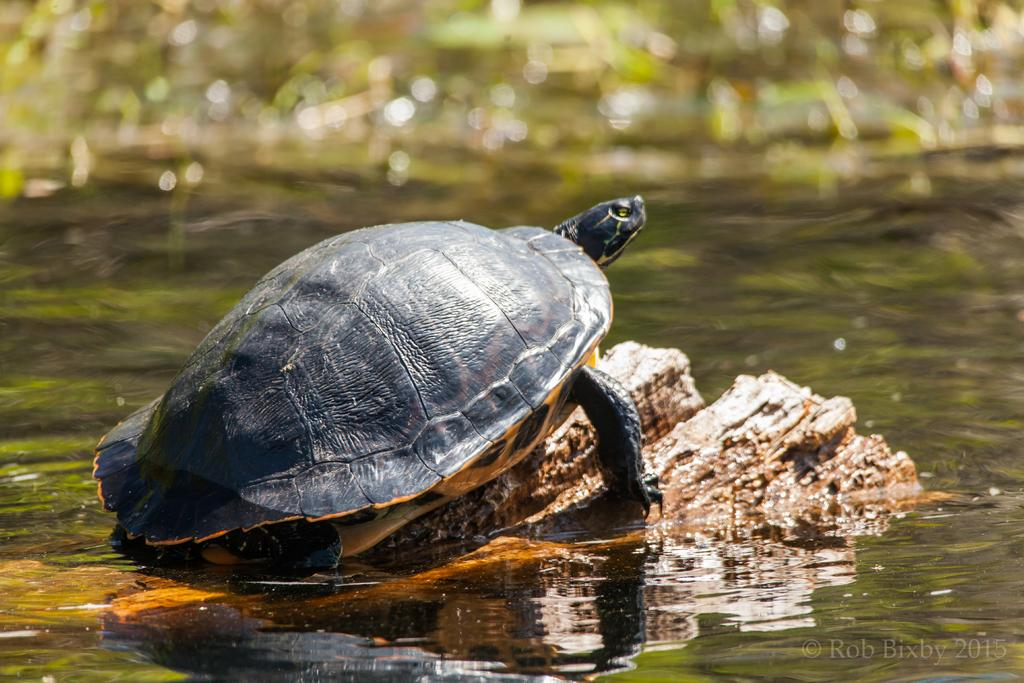What type of animal is in the image? There is a black tortoise in the image. What is the tortoise standing on in the image? The tortoise is on a rock. What natural element is visible in the image? There is water visible in the image. What type of jar can be seen in the image? There is no jar present in the image. Is there any blood visible in the image? There is no blood visible in the image. What type of coil can be seen in the image? There is no coil present in the image. 